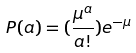<formula> <loc_0><loc_0><loc_500><loc_500>P ( a ) = ( \frac { \mu ^ { a } } { a ! } ) e ^ { - \mu }</formula> 